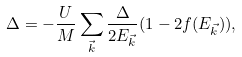Convert formula to latex. <formula><loc_0><loc_0><loc_500><loc_500>\Delta = - \frac { U } { M } \sum _ { \vec { k } } \frac { \Delta } { 2 E _ { \vec { k } } } ( 1 - 2 f ( E _ { \vec { k } } ) ) ,</formula> 